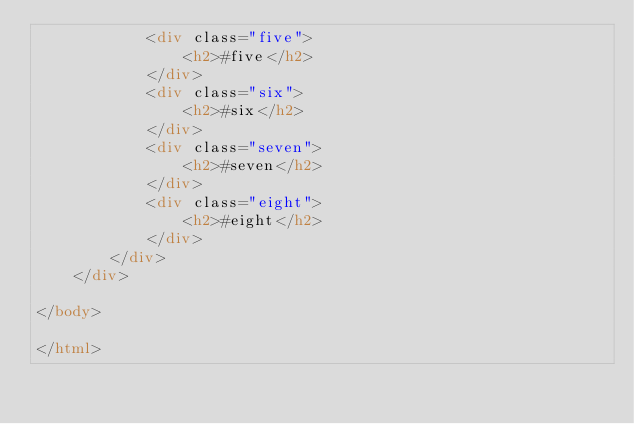Convert code to text. <code><loc_0><loc_0><loc_500><loc_500><_HTML_>            <div class="five">
                <h2>#five</h2>
            </div>
            <div class="six">
                <h2>#six</h2>
            </div>
            <div class="seven">
                <h2>#seven</h2>
            </div>
            <div class="eight">
                <h2>#eight</h2>
            </div>
        </div>
    </div>

</body>

</html>
</code> 